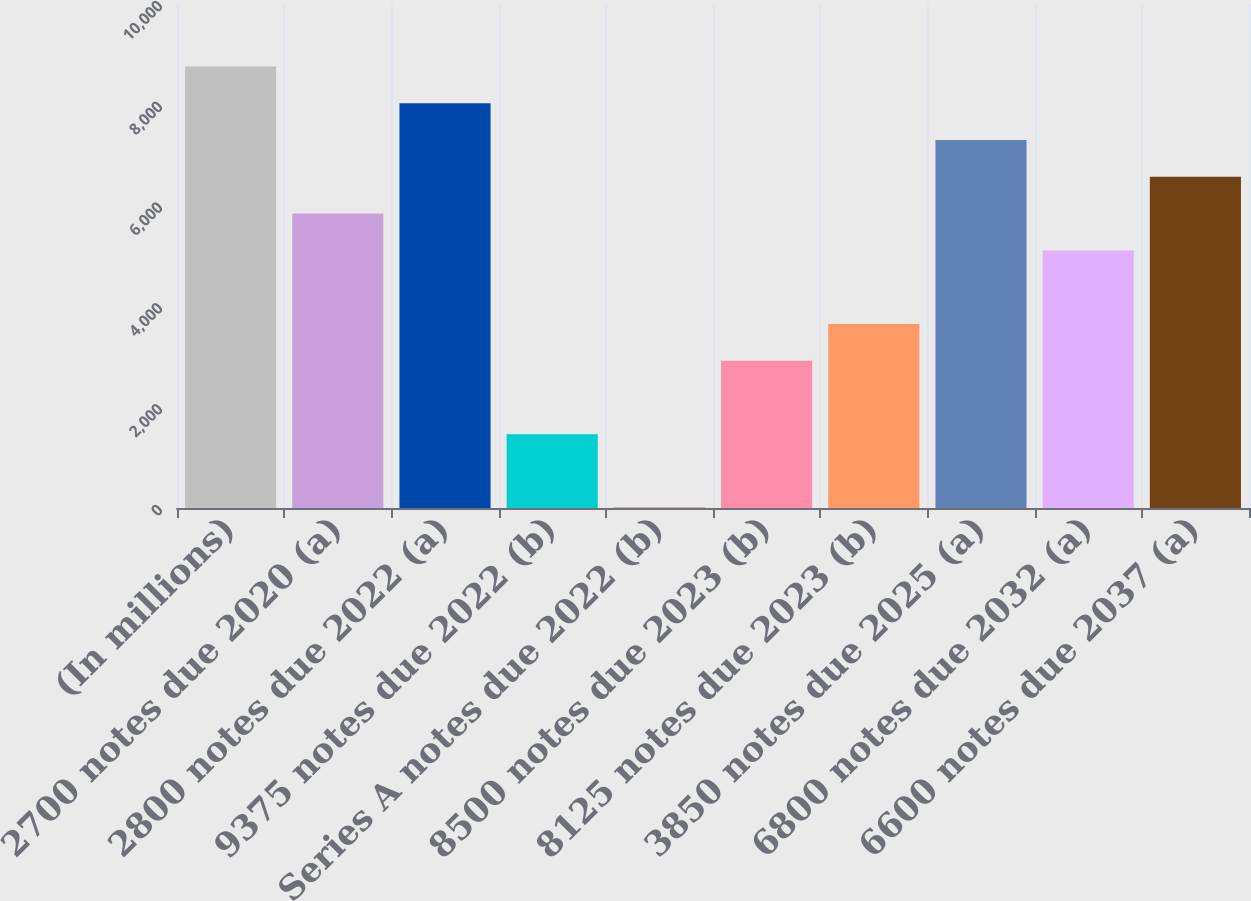<chart> <loc_0><loc_0><loc_500><loc_500><bar_chart><fcel>(In millions)<fcel>2700 notes due 2020 (a)<fcel>2800 notes due 2022 (a)<fcel>9375 notes due 2022 (b)<fcel>Series A notes due 2022 (b)<fcel>8500 notes due 2023 (b)<fcel>8125 notes due 2023 (b)<fcel>3850 notes due 2025 (a)<fcel>6800 notes due 2032 (a)<fcel>6600 notes due 2037 (a)<nl><fcel>8760.6<fcel>5841.4<fcel>8030.8<fcel>1462.6<fcel>3<fcel>2922.2<fcel>3652<fcel>7301<fcel>5111.6<fcel>6571.2<nl></chart> 